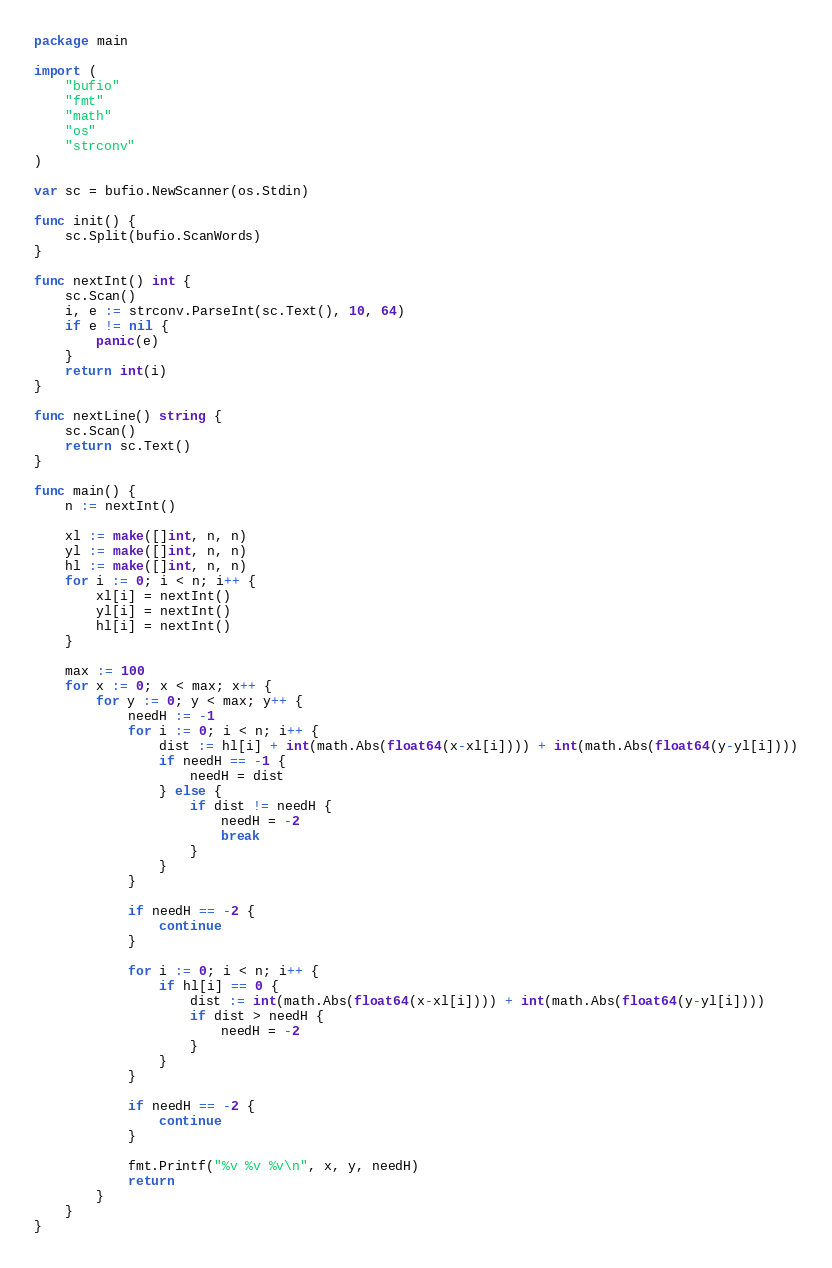Convert code to text. <code><loc_0><loc_0><loc_500><loc_500><_Go_>package main

import (
	"bufio"
	"fmt"
	"math"
	"os"
	"strconv"
)

var sc = bufio.NewScanner(os.Stdin)

func init() {
	sc.Split(bufio.ScanWords)
}

func nextInt() int {
	sc.Scan()
	i, e := strconv.ParseInt(sc.Text(), 10, 64)
	if e != nil {
		panic(e)
	}
	return int(i)
}

func nextLine() string {
	sc.Scan()
	return sc.Text()
}

func main() {
	n := nextInt()

	xl := make([]int, n, n)
	yl := make([]int, n, n)
	hl := make([]int, n, n)
	for i := 0; i < n; i++ {
		xl[i] = nextInt()
		yl[i] = nextInt()
		hl[i] = nextInt()
	}

	max := 100
	for x := 0; x < max; x++ {
		for y := 0; y < max; y++ {
			needH := -1
			for i := 0; i < n; i++ {
				dist := hl[i] + int(math.Abs(float64(x-xl[i]))) + int(math.Abs(float64(y-yl[i])))
				if needH == -1 {
					needH = dist
				} else {
					if dist != needH {
						needH = -2
						break
					}
				}
			}

			if needH == -2 {
				continue
			}

			for i := 0; i < n; i++ {
				if hl[i] == 0 {
					dist := int(math.Abs(float64(x-xl[i]))) + int(math.Abs(float64(y-yl[i])))
					if dist > needH {
						needH = -2
					}
				}
			}

			if needH == -2 {
				continue
			}

			fmt.Printf("%v %v %v\n", x, y, needH)
			return
		}
	}
}
</code> 